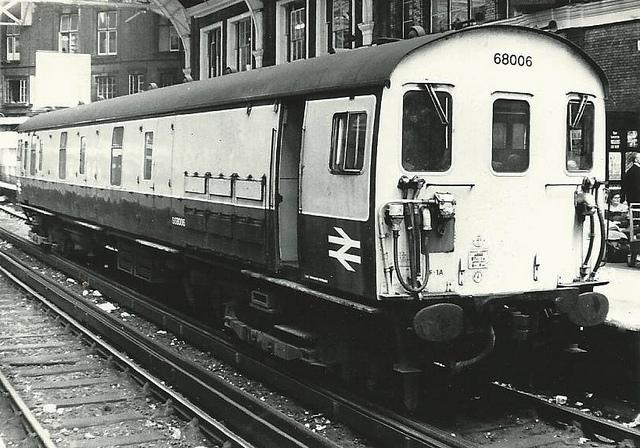What number is the largest number on the train? eight 